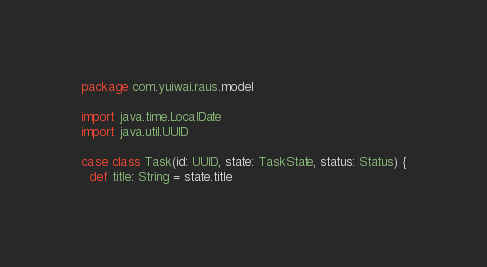<code> <loc_0><loc_0><loc_500><loc_500><_Scala_>package com.yuiwai.raus.model

import java.time.LocalDate
import java.util.UUID

case class Task(id: UUID, state: TaskState, status: Status) {
  def title: String = state.title</code> 